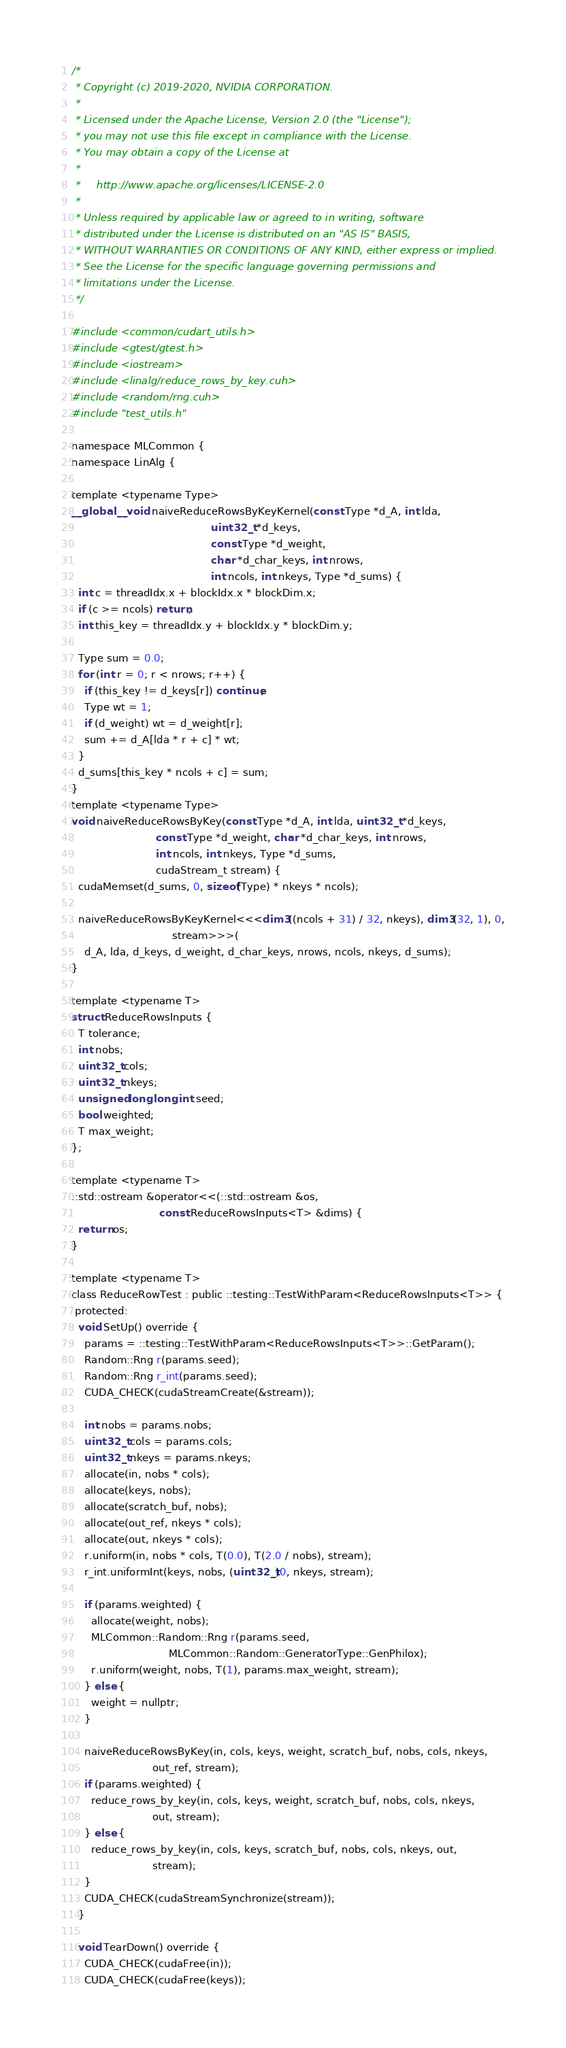<code> <loc_0><loc_0><loc_500><loc_500><_Cuda_>/*
 * Copyright (c) 2019-2020, NVIDIA CORPORATION.
 *
 * Licensed under the Apache License, Version 2.0 (the "License");
 * you may not use this file except in compliance with the License.
 * You may obtain a copy of the License at
 *
 *     http://www.apache.org/licenses/LICENSE-2.0
 *
 * Unless required by applicable law or agreed to in writing, software
 * distributed under the License is distributed on an "AS IS" BASIS,
 * WITHOUT WARRANTIES OR CONDITIONS OF ANY KIND, either express or implied.
 * See the License for the specific language governing permissions and
 * limitations under the License.
 */

#include <common/cudart_utils.h>
#include <gtest/gtest.h>
#include <iostream>
#include <linalg/reduce_rows_by_key.cuh>
#include <random/rng.cuh>
#include "test_utils.h"

namespace MLCommon {
namespace LinAlg {

template <typename Type>
__global__ void naiveReduceRowsByKeyKernel(const Type *d_A, int lda,
                                           uint32_t *d_keys,
                                           const Type *d_weight,
                                           char *d_char_keys, int nrows,
                                           int ncols, int nkeys, Type *d_sums) {
  int c = threadIdx.x + blockIdx.x * blockDim.x;
  if (c >= ncols) return;
  int this_key = threadIdx.y + blockIdx.y * blockDim.y;

  Type sum = 0.0;
  for (int r = 0; r < nrows; r++) {
    if (this_key != d_keys[r]) continue;
    Type wt = 1;
    if (d_weight) wt = d_weight[r];
    sum += d_A[lda * r + c] * wt;
  }
  d_sums[this_key * ncols + c] = sum;
}
template <typename Type>
void naiveReduceRowsByKey(const Type *d_A, int lda, uint32_t *d_keys,
                          const Type *d_weight, char *d_char_keys, int nrows,
                          int ncols, int nkeys, Type *d_sums,
                          cudaStream_t stream) {
  cudaMemset(d_sums, 0, sizeof(Type) * nkeys * ncols);

  naiveReduceRowsByKeyKernel<<<dim3((ncols + 31) / 32, nkeys), dim3(32, 1), 0,
                               stream>>>(
    d_A, lda, d_keys, d_weight, d_char_keys, nrows, ncols, nkeys, d_sums);
}

template <typename T>
struct ReduceRowsInputs {
  T tolerance;
  int nobs;
  uint32_t cols;
  uint32_t nkeys;
  unsigned long long int seed;
  bool weighted;
  T max_weight;
};

template <typename T>
::std::ostream &operator<<(::std::ostream &os,
                           const ReduceRowsInputs<T> &dims) {
  return os;
}

template <typename T>
class ReduceRowTest : public ::testing::TestWithParam<ReduceRowsInputs<T>> {
 protected:
  void SetUp() override {
    params = ::testing::TestWithParam<ReduceRowsInputs<T>>::GetParam();
    Random::Rng r(params.seed);
    Random::Rng r_int(params.seed);
    CUDA_CHECK(cudaStreamCreate(&stream));

    int nobs = params.nobs;
    uint32_t cols = params.cols;
    uint32_t nkeys = params.nkeys;
    allocate(in, nobs * cols);
    allocate(keys, nobs);
    allocate(scratch_buf, nobs);
    allocate(out_ref, nkeys * cols);
    allocate(out, nkeys * cols);
    r.uniform(in, nobs * cols, T(0.0), T(2.0 / nobs), stream);
    r_int.uniformInt(keys, nobs, (uint32_t)0, nkeys, stream);

    if (params.weighted) {
      allocate(weight, nobs);
      MLCommon::Random::Rng r(params.seed,
                              MLCommon::Random::GeneratorType::GenPhilox);
      r.uniform(weight, nobs, T(1), params.max_weight, stream);
    } else {
      weight = nullptr;
    }

    naiveReduceRowsByKey(in, cols, keys, weight, scratch_buf, nobs, cols, nkeys,
                         out_ref, stream);
    if (params.weighted) {
      reduce_rows_by_key(in, cols, keys, weight, scratch_buf, nobs, cols, nkeys,
                         out, stream);
    } else {
      reduce_rows_by_key(in, cols, keys, scratch_buf, nobs, cols, nkeys, out,
                         stream);
    }
    CUDA_CHECK(cudaStreamSynchronize(stream));
  }

  void TearDown() override {
    CUDA_CHECK(cudaFree(in));
    CUDA_CHECK(cudaFree(keys));</code> 